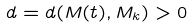<formula> <loc_0><loc_0><loc_500><loc_500>d = d ( M ( t ) , M _ { k } ) > 0</formula> 